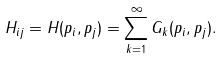Convert formula to latex. <formula><loc_0><loc_0><loc_500><loc_500>H _ { i j } = H ( { p _ { i } } , { p _ { j } } ) = \sum _ { k = 1 } ^ { \infty } G _ { k } ( { p _ { i } } , { p _ { j } } ) .</formula> 